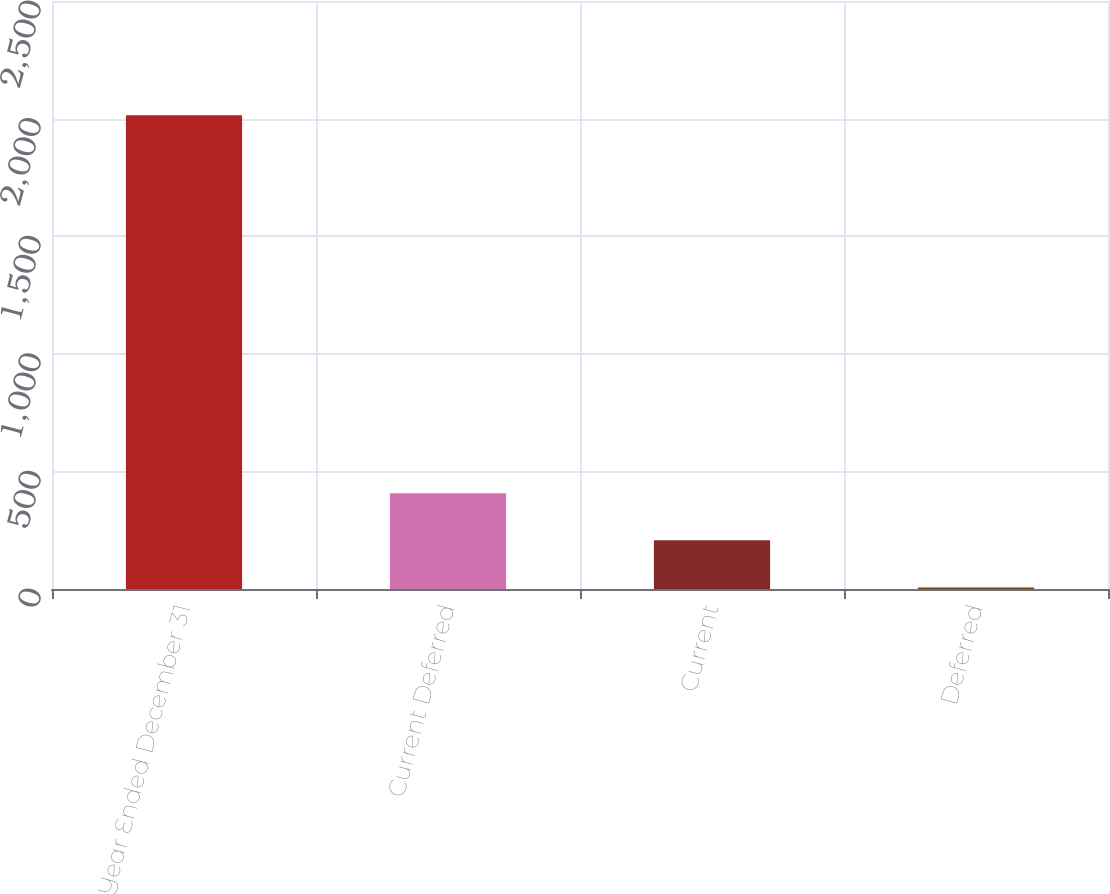Convert chart to OTSL. <chart><loc_0><loc_0><loc_500><loc_500><bar_chart><fcel>Year Ended December 31<fcel>Current Deferred<fcel>Current<fcel>Deferred<nl><fcel>2014<fcel>407.6<fcel>206.8<fcel>6<nl></chart> 